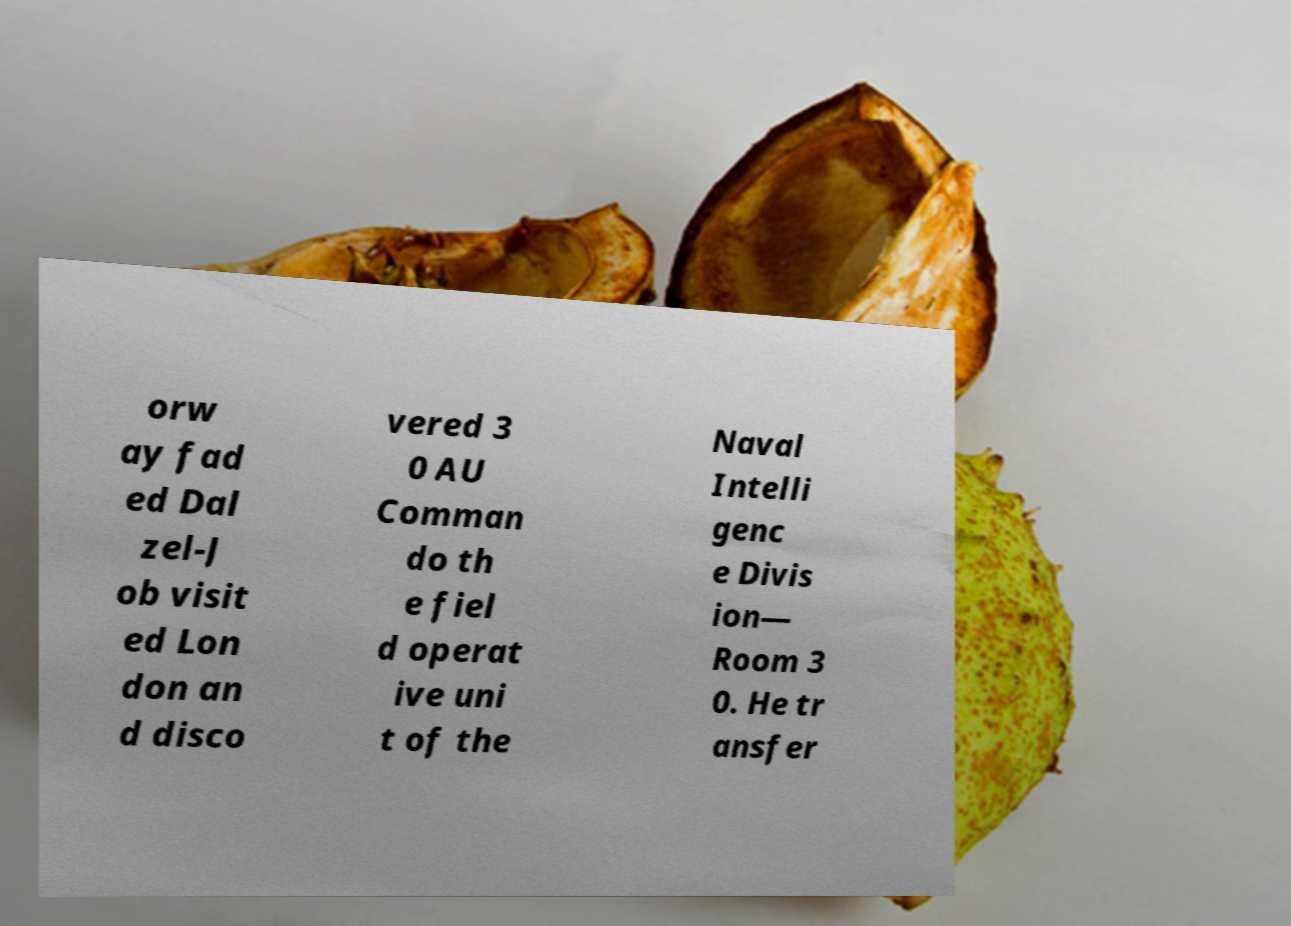Could you assist in decoding the text presented in this image and type it out clearly? orw ay fad ed Dal zel-J ob visit ed Lon don an d disco vered 3 0 AU Comman do th e fiel d operat ive uni t of the Naval Intelli genc e Divis ion— Room 3 0. He tr ansfer 